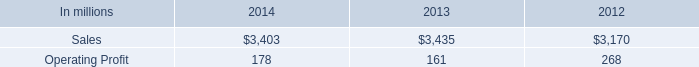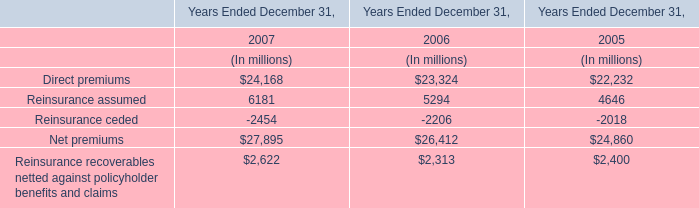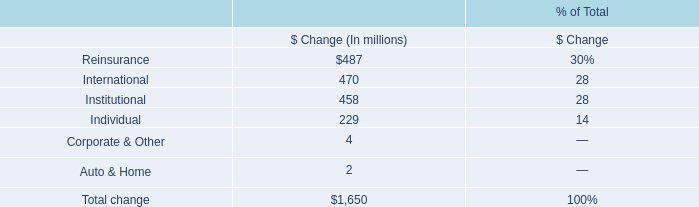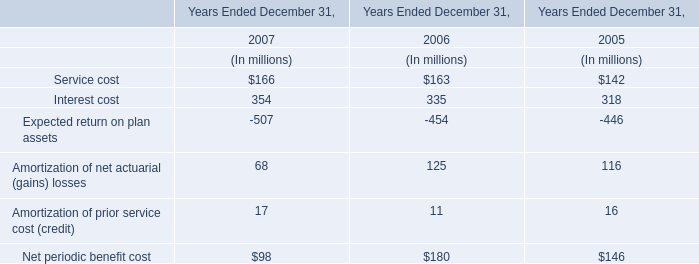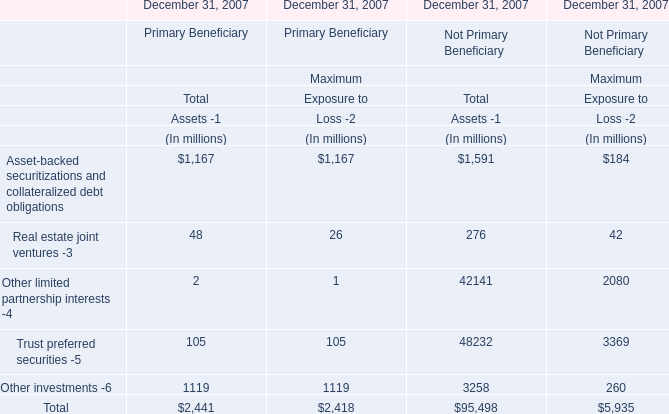What's the average of Maximum Exposure to Loss -2 of Primary Beneficiary in 2007? (in million) 
Computations: (2418 / 5)
Answer: 483.6. 